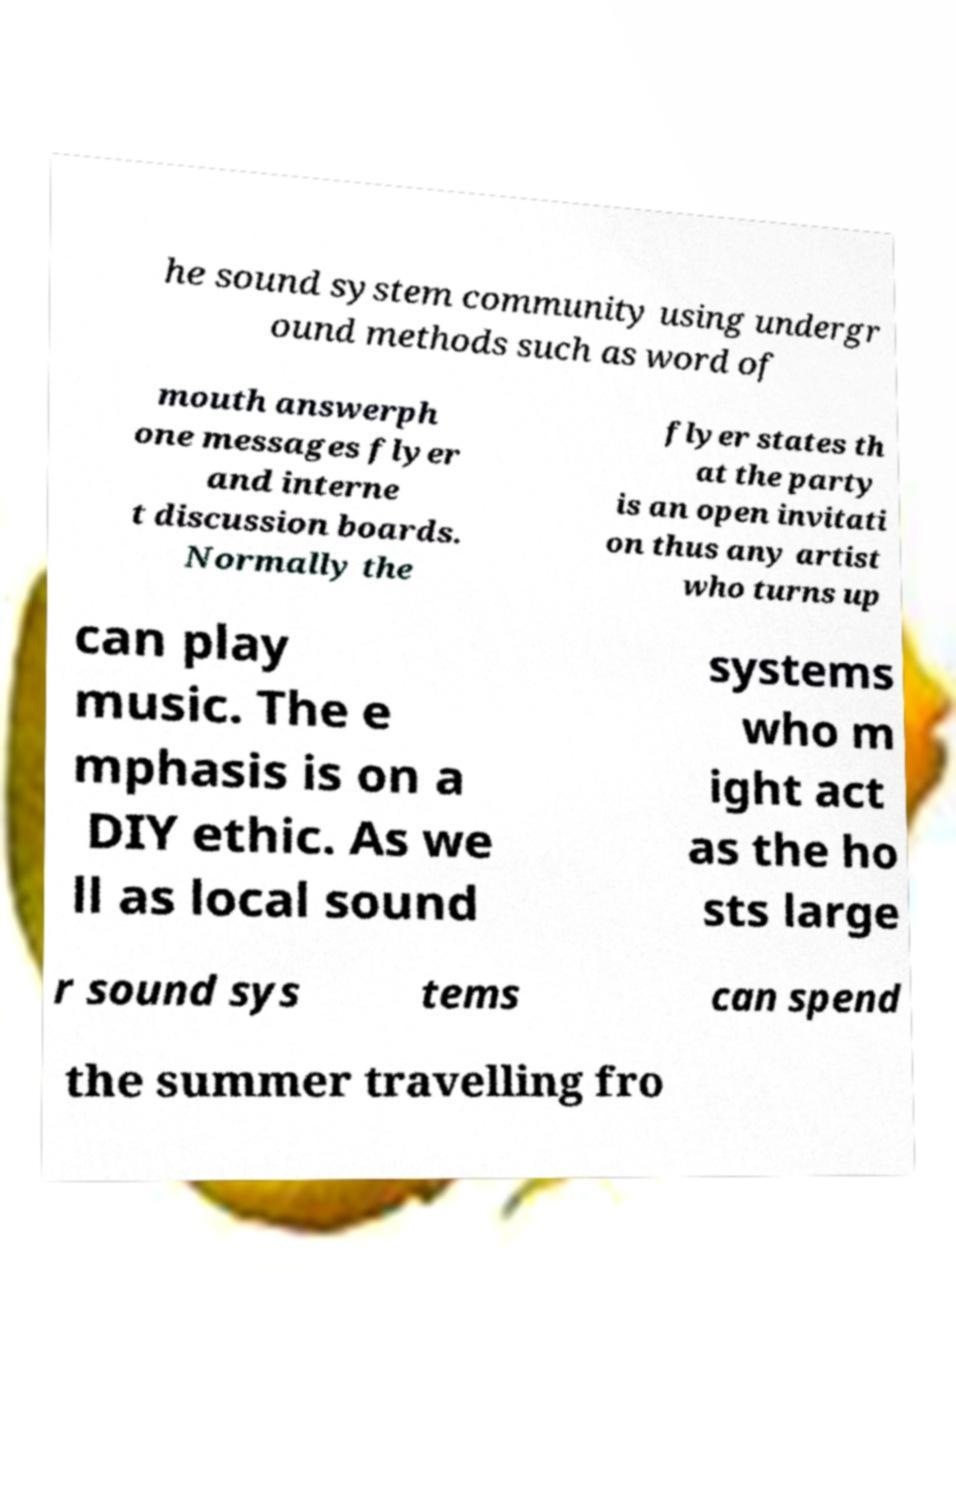Please identify and transcribe the text found in this image. he sound system community using undergr ound methods such as word of mouth answerph one messages flyer and interne t discussion boards. Normally the flyer states th at the party is an open invitati on thus any artist who turns up can play music. The e mphasis is on a DIY ethic. As we ll as local sound systems who m ight act as the ho sts large r sound sys tems can spend the summer travelling fro 